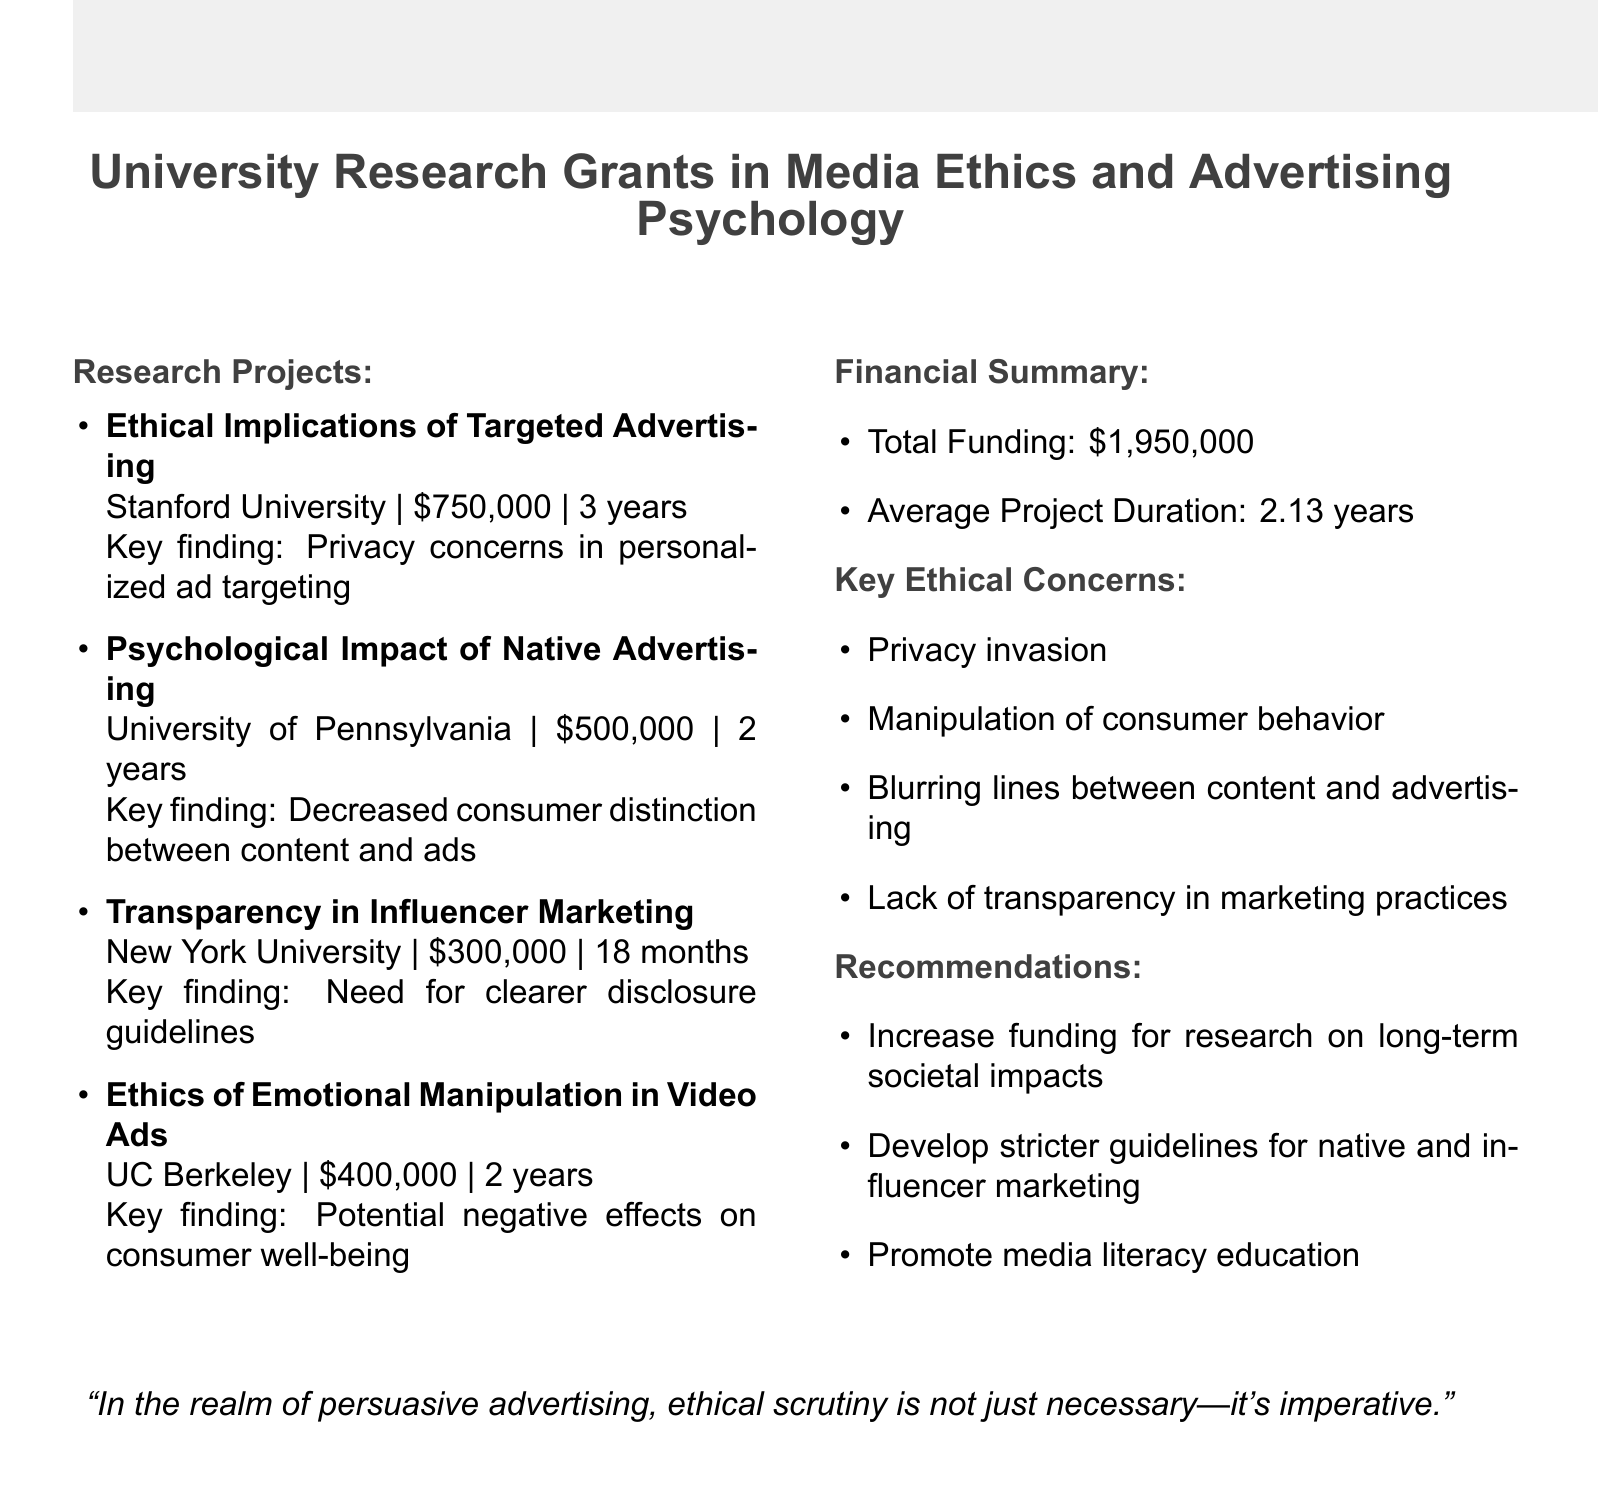What is the total funding amount for the research grants? The total funding amount is listed in the financial summary of the document.
Answer: $1,950,000 Who is the principal investigator of the project on targeted advertising? The document provides the name of the principal investigator for each project, including targeted advertising.
Answer: Dr. Sarah Martinez What institution conducted the research on native advertising? The document specifies the institution associated with each research project.
Answer: University of Pennsylvania How long is the duration of the project on influencer marketing? The document indicates the duration of each project, including the one on influencer marketing.
Answer: 18 months What key ethical concern is highlighted in the research findings? Multiple key ethical concerns are listed in the document, which summarize the main issues identified.
Answer: Privacy invasion How many research projects are listed in the document? The number of research projects can be determined by counting the items listed under research projects.
Answer: 4 What are the recommendations for ethical advertising practices? The document includes a list of recommendations related to ethical practices in advertising.
Answer: Increase funding for research on long-term societal impacts of persuasive advertising Which project focused on emotional manipulation in advertising? Each project is briefly described, including the one focusing on emotional manipulation in video advertising.
Answer: The Ethics of Emotional Manipulation in Video Advertising 